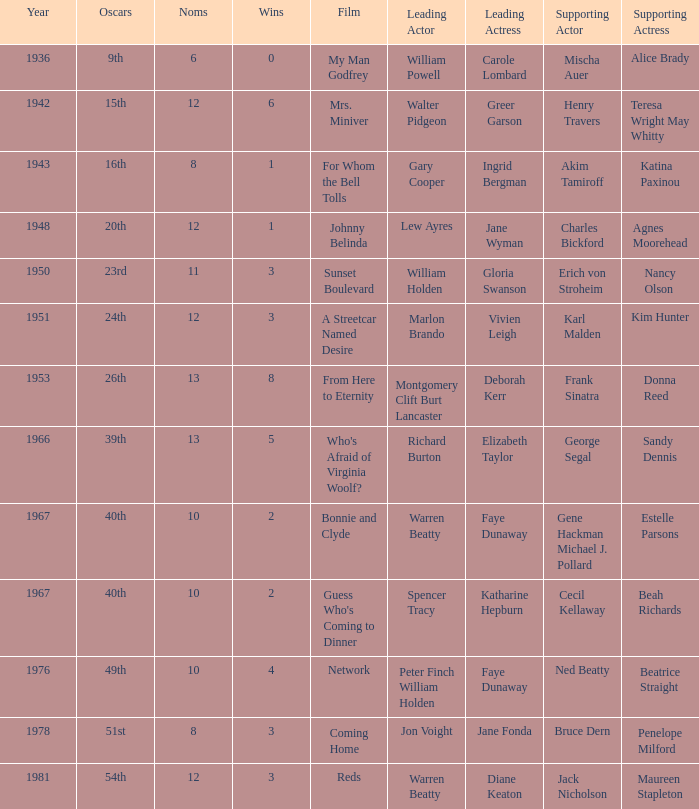In the movie featuring cecil kellaway as a supporting actor, who played the main role? Spencer Tracy. 